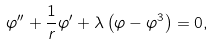<formula> <loc_0><loc_0><loc_500><loc_500>\varphi ^ { \prime \prime } + { \frac { 1 } { r } } \varphi ^ { \prime } + \lambda \left ( \varphi - \varphi ^ { 3 } \right ) = 0 ,</formula> 